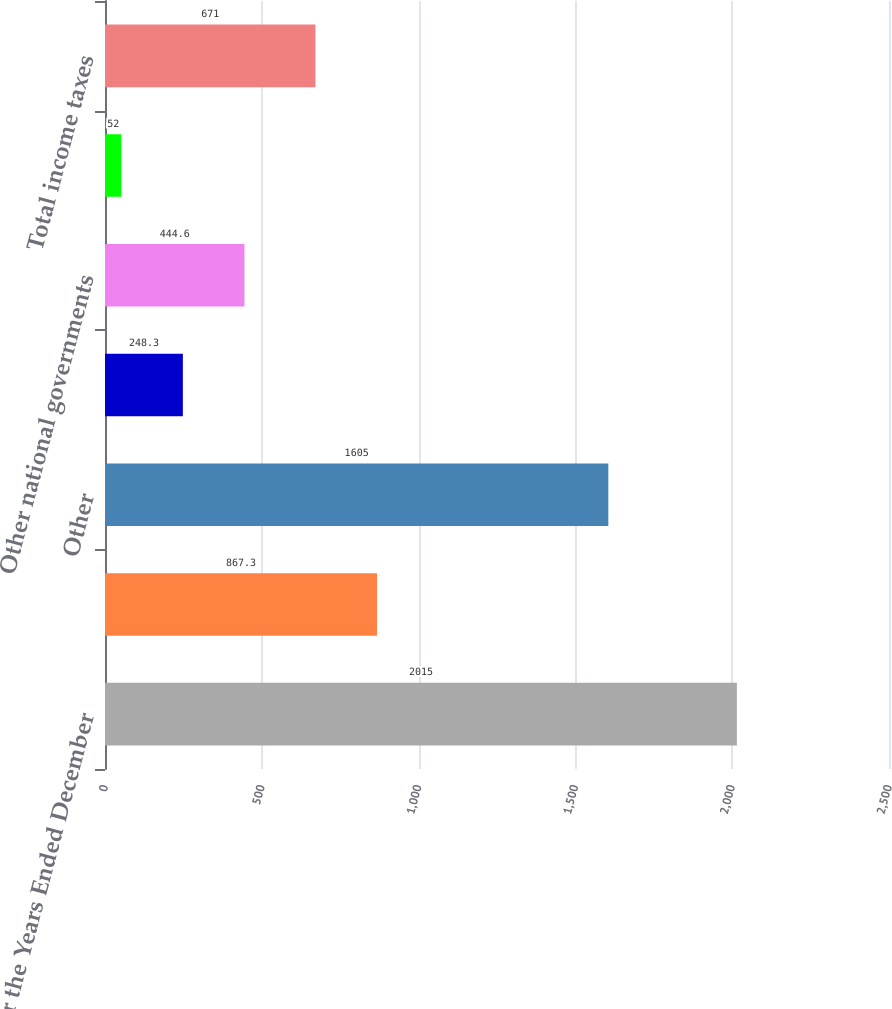<chart> <loc_0><loc_0><loc_500><loc_500><bar_chart><fcel>For the Years Ended December<fcel>US<fcel>Other<fcel>US Federal<fcel>Other national governments<fcel>US state and local<fcel>Total income taxes<nl><fcel>2015<fcel>867.3<fcel>1605<fcel>248.3<fcel>444.6<fcel>52<fcel>671<nl></chart> 